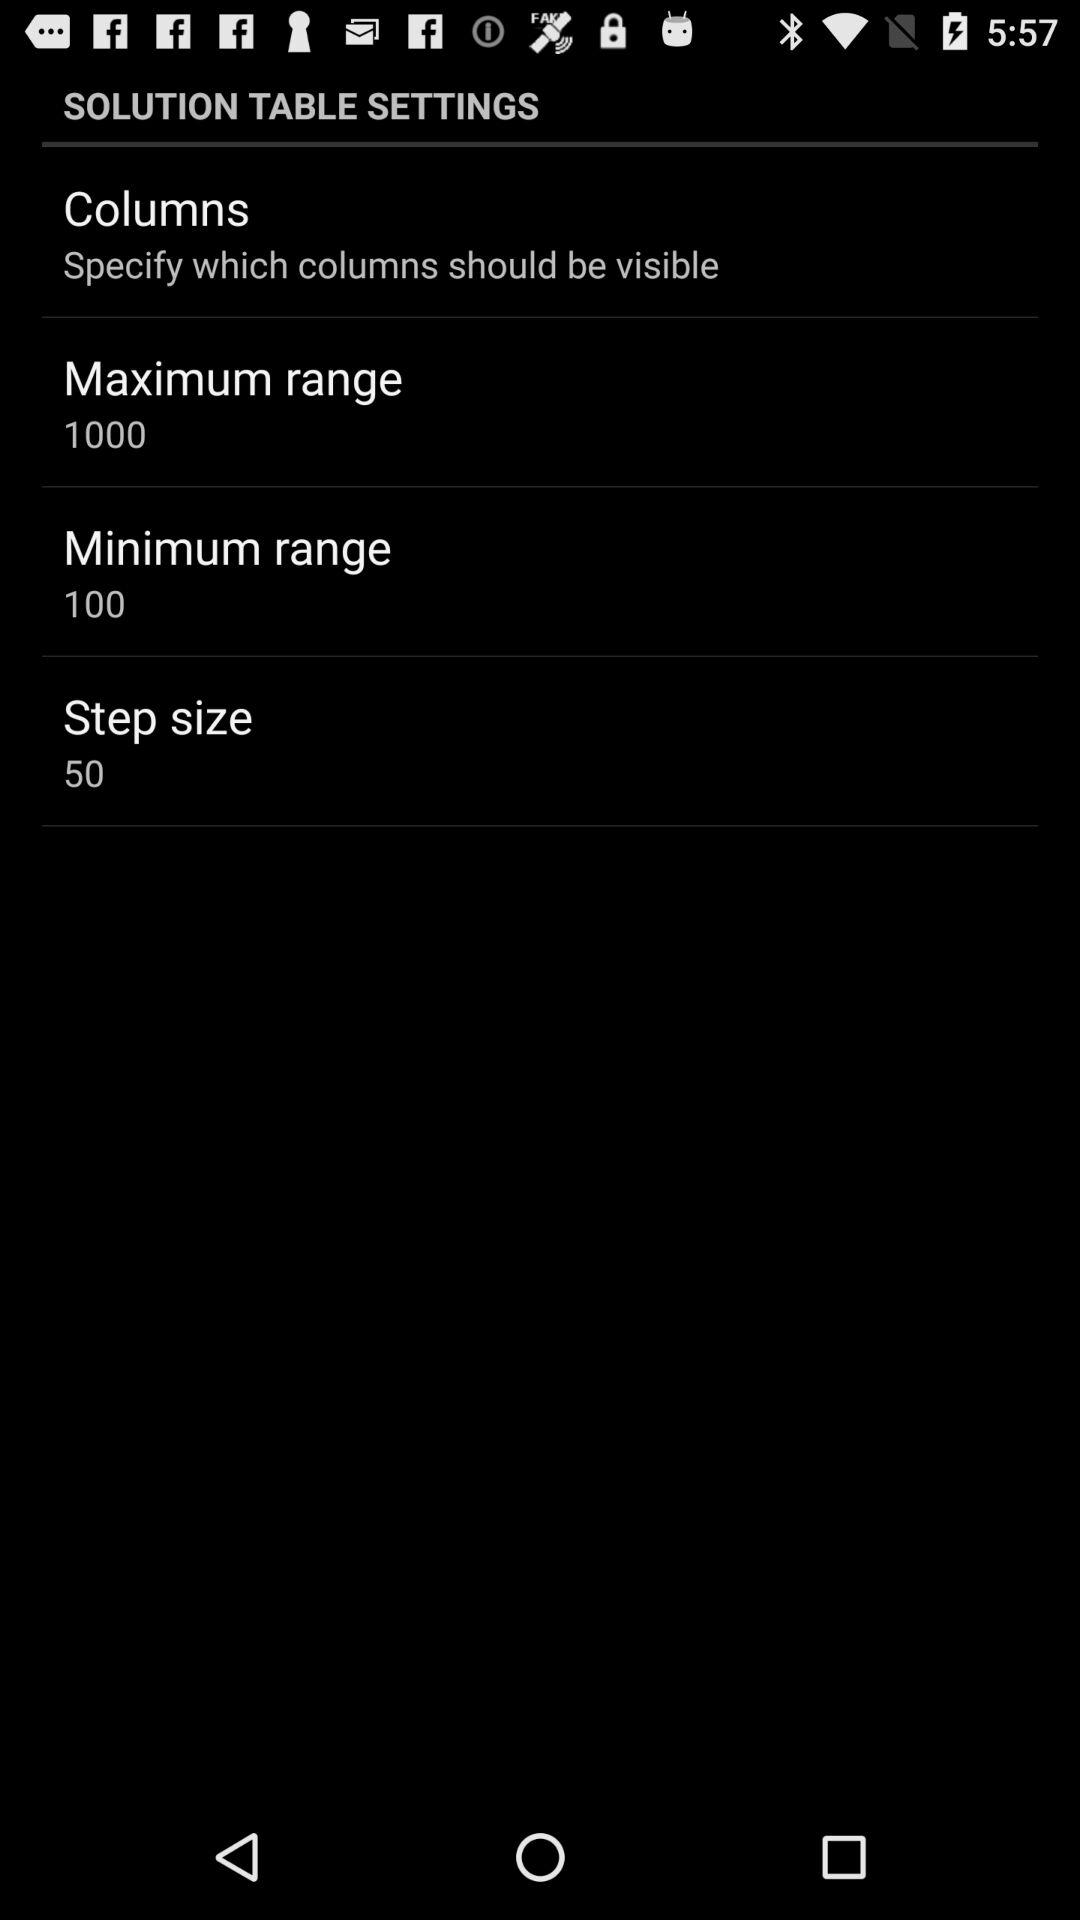What is the minimum range? The minimum range is 100. 